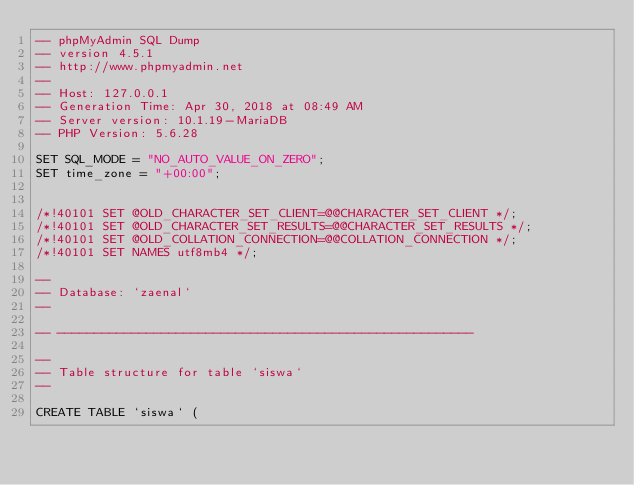<code> <loc_0><loc_0><loc_500><loc_500><_SQL_>-- phpMyAdmin SQL Dump
-- version 4.5.1
-- http://www.phpmyadmin.net
--
-- Host: 127.0.0.1
-- Generation Time: Apr 30, 2018 at 08:49 AM
-- Server version: 10.1.19-MariaDB
-- PHP Version: 5.6.28

SET SQL_MODE = "NO_AUTO_VALUE_ON_ZERO";
SET time_zone = "+00:00";


/*!40101 SET @OLD_CHARACTER_SET_CLIENT=@@CHARACTER_SET_CLIENT */;
/*!40101 SET @OLD_CHARACTER_SET_RESULTS=@@CHARACTER_SET_RESULTS */;
/*!40101 SET @OLD_COLLATION_CONNECTION=@@COLLATION_CONNECTION */;
/*!40101 SET NAMES utf8mb4 */;

--
-- Database: `zaenal`
--

-- --------------------------------------------------------

--
-- Table structure for table `siswa`
--

CREATE TABLE `siswa` (</code> 